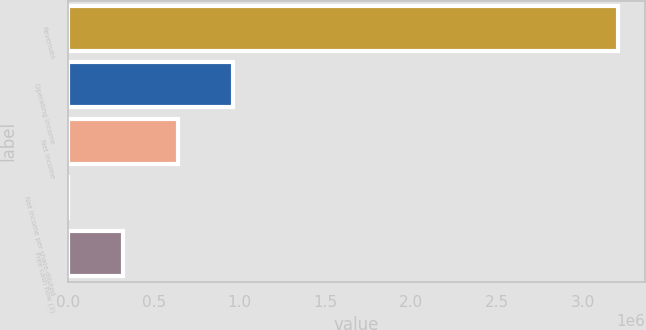Convert chart to OTSL. <chart><loc_0><loc_0><loc_500><loc_500><bar_chart><fcel>Revenues<fcel>Operating income<fcel>Net income<fcel>Net income per share-diluted<fcel>Free cash flow (3)<nl><fcel>3.20458e+06<fcel>961376<fcel>640919<fcel>4.16<fcel>320461<nl></chart> 